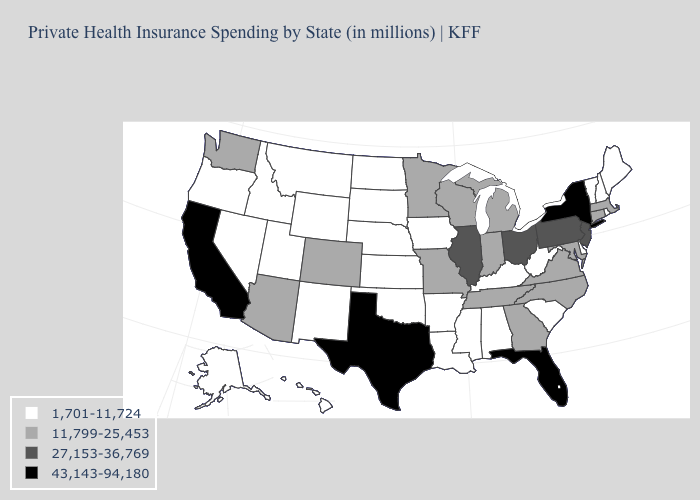Name the states that have a value in the range 1,701-11,724?
Concise answer only. Alabama, Alaska, Arkansas, Delaware, Hawaii, Idaho, Iowa, Kansas, Kentucky, Louisiana, Maine, Mississippi, Montana, Nebraska, Nevada, New Hampshire, New Mexico, North Dakota, Oklahoma, Oregon, Rhode Island, South Carolina, South Dakota, Utah, Vermont, West Virginia, Wyoming. What is the value of North Carolina?
Quick response, please. 11,799-25,453. Name the states that have a value in the range 1,701-11,724?
Answer briefly. Alabama, Alaska, Arkansas, Delaware, Hawaii, Idaho, Iowa, Kansas, Kentucky, Louisiana, Maine, Mississippi, Montana, Nebraska, Nevada, New Hampshire, New Mexico, North Dakota, Oklahoma, Oregon, Rhode Island, South Carolina, South Dakota, Utah, Vermont, West Virginia, Wyoming. Name the states that have a value in the range 1,701-11,724?
Keep it brief. Alabama, Alaska, Arkansas, Delaware, Hawaii, Idaho, Iowa, Kansas, Kentucky, Louisiana, Maine, Mississippi, Montana, Nebraska, Nevada, New Hampshire, New Mexico, North Dakota, Oklahoma, Oregon, Rhode Island, South Carolina, South Dakota, Utah, Vermont, West Virginia, Wyoming. Name the states that have a value in the range 43,143-94,180?
Answer briefly. California, Florida, New York, Texas. What is the highest value in the Northeast ?
Answer briefly. 43,143-94,180. Does Kansas have a lower value than Arizona?
Short answer required. Yes. Among the states that border Mississippi , which have the lowest value?
Keep it brief. Alabama, Arkansas, Louisiana. Among the states that border New York , does Connecticut have the lowest value?
Answer briefly. No. Among the states that border Georgia , which have the lowest value?
Write a very short answer. Alabama, South Carolina. Does Nebraska have the lowest value in the MidWest?
Keep it brief. Yes. Does California have the highest value in the USA?
Give a very brief answer. Yes. Name the states that have a value in the range 1,701-11,724?
Write a very short answer. Alabama, Alaska, Arkansas, Delaware, Hawaii, Idaho, Iowa, Kansas, Kentucky, Louisiana, Maine, Mississippi, Montana, Nebraska, Nevada, New Hampshire, New Mexico, North Dakota, Oklahoma, Oregon, Rhode Island, South Carolina, South Dakota, Utah, Vermont, West Virginia, Wyoming. What is the value of North Carolina?
Answer briefly. 11,799-25,453. What is the value of Connecticut?
Be succinct. 11,799-25,453. 